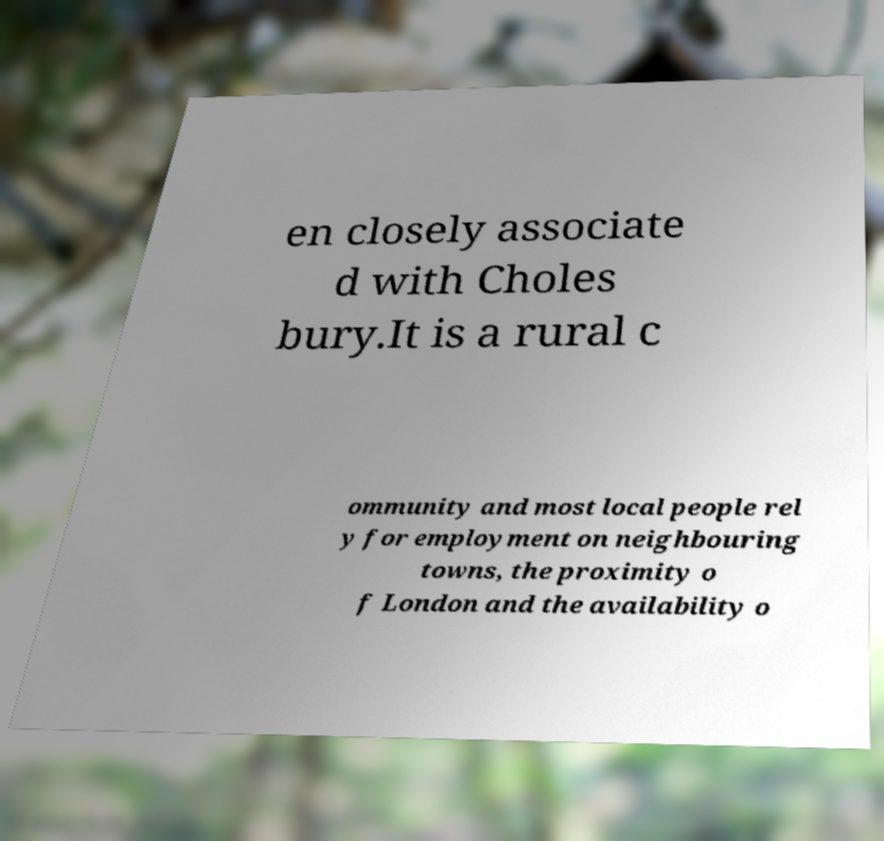Can you read and provide the text displayed in the image?This photo seems to have some interesting text. Can you extract and type it out for me? en closely associate d with Choles bury.It is a rural c ommunity and most local people rel y for employment on neighbouring towns, the proximity o f London and the availability o 